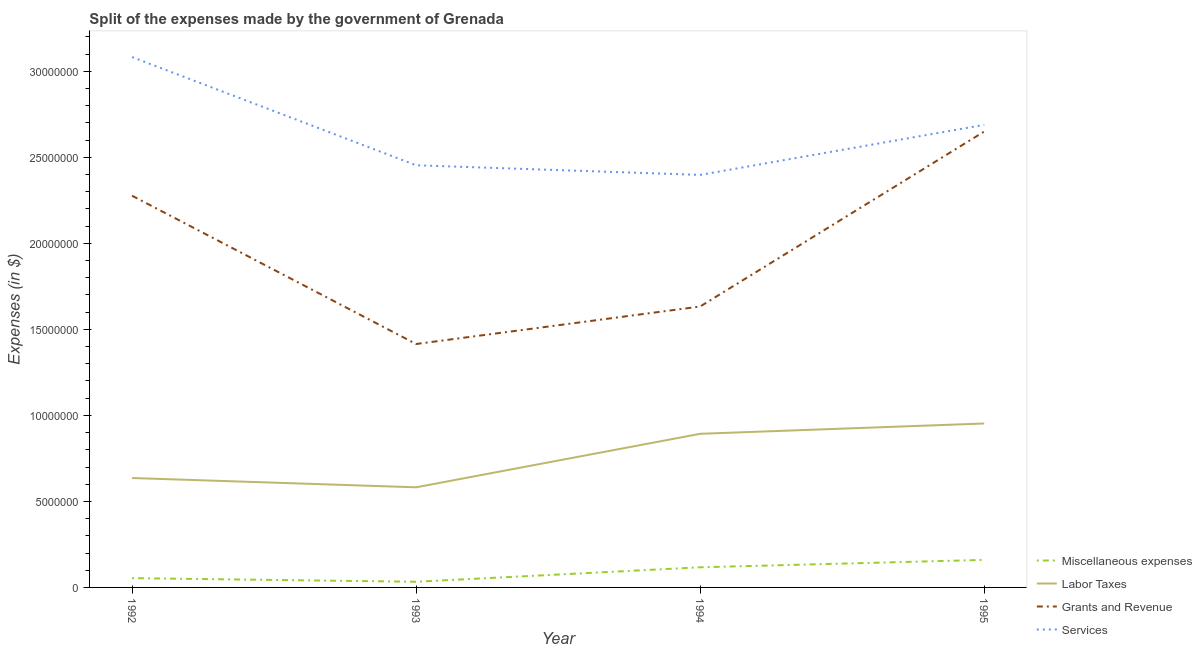How many different coloured lines are there?
Your answer should be very brief. 4. What is the amount spent on services in 1995?
Provide a short and direct response. 2.69e+07. Across all years, what is the maximum amount spent on services?
Offer a terse response. 3.08e+07. Across all years, what is the minimum amount spent on services?
Make the answer very short. 2.40e+07. In which year was the amount spent on grants and revenue minimum?
Offer a terse response. 1993. What is the total amount spent on miscellaneous expenses in the graph?
Make the answer very short. 3.64e+06. What is the difference between the amount spent on grants and revenue in 1994 and that in 1995?
Provide a succinct answer. -1.02e+07. What is the difference between the amount spent on services in 1992 and the amount spent on miscellaneous expenses in 1995?
Your answer should be very brief. 2.92e+07. What is the average amount spent on grants and revenue per year?
Make the answer very short. 1.99e+07. In the year 1992, what is the difference between the amount spent on miscellaneous expenses and amount spent on grants and revenue?
Offer a very short reply. -2.22e+07. What is the ratio of the amount spent on grants and revenue in 1993 to that in 1995?
Make the answer very short. 0.53. Is the difference between the amount spent on services in 1993 and 1994 greater than the difference between the amount spent on labor taxes in 1993 and 1994?
Offer a very short reply. Yes. What is the difference between the highest and the second highest amount spent on grants and revenue?
Ensure brevity in your answer.  3.73e+06. What is the difference between the highest and the lowest amount spent on labor taxes?
Give a very brief answer. 3.71e+06. Is the sum of the amount spent on labor taxes in 1992 and 1994 greater than the maximum amount spent on miscellaneous expenses across all years?
Ensure brevity in your answer.  Yes. Is it the case that in every year, the sum of the amount spent on services and amount spent on miscellaneous expenses is greater than the sum of amount spent on grants and revenue and amount spent on labor taxes?
Your response must be concise. Yes. Is it the case that in every year, the sum of the amount spent on miscellaneous expenses and amount spent on labor taxes is greater than the amount spent on grants and revenue?
Your answer should be compact. No. Does the amount spent on labor taxes monotonically increase over the years?
Provide a succinct answer. No. Is the amount spent on grants and revenue strictly greater than the amount spent on services over the years?
Offer a terse response. No. Where does the legend appear in the graph?
Offer a terse response. Bottom right. How many legend labels are there?
Offer a very short reply. 4. What is the title of the graph?
Ensure brevity in your answer.  Split of the expenses made by the government of Grenada. What is the label or title of the X-axis?
Give a very brief answer. Year. What is the label or title of the Y-axis?
Give a very brief answer. Expenses (in $). What is the Expenses (in $) in Miscellaneous expenses in 1992?
Provide a succinct answer. 5.40e+05. What is the Expenses (in $) of Labor Taxes in 1992?
Provide a succinct answer. 6.36e+06. What is the Expenses (in $) of Grants and Revenue in 1992?
Provide a succinct answer. 2.28e+07. What is the Expenses (in $) of Services in 1992?
Ensure brevity in your answer.  3.08e+07. What is the Expenses (in $) in Miscellaneous expenses in 1993?
Offer a very short reply. 3.30e+05. What is the Expenses (in $) in Labor Taxes in 1993?
Provide a short and direct response. 5.82e+06. What is the Expenses (in $) in Grants and Revenue in 1993?
Your answer should be very brief. 1.42e+07. What is the Expenses (in $) in Services in 1993?
Give a very brief answer. 2.45e+07. What is the Expenses (in $) of Miscellaneous expenses in 1994?
Provide a succinct answer. 1.17e+06. What is the Expenses (in $) of Labor Taxes in 1994?
Offer a terse response. 8.93e+06. What is the Expenses (in $) of Grants and Revenue in 1994?
Your answer should be very brief. 1.63e+07. What is the Expenses (in $) in Services in 1994?
Your response must be concise. 2.40e+07. What is the Expenses (in $) of Miscellaneous expenses in 1995?
Give a very brief answer. 1.60e+06. What is the Expenses (in $) in Labor Taxes in 1995?
Ensure brevity in your answer.  9.53e+06. What is the Expenses (in $) in Grants and Revenue in 1995?
Provide a short and direct response. 2.65e+07. What is the Expenses (in $) in Services in 1995?
Give a very brief answer. 2.69e+07. Across all years, what is the maximum Expenses (in $) of Miscellaneous expenses?
Offer a terse response. 1.60e+06. Across all years, what is the maximum Expenses (in $) in Labor Taxes?
Your answer should be compact. 9.53e+06. Across all years, what is the maximum Expenses (in $) of Grants and Revenue?
Offer a very short reply. 2.65e+07. Across all years, what is the maximum Expenses (in $) of Services?
Your answer should be very brief. 3.08e+07. Across all years, what is the minimum Expenses (in $) in Labor Taxes?
Ensure brevity in your answer.  5.82e+06. Across all years, what is the minimum Expenses (in $) of Grants and Revenue?
Make the answer very short. 1.42e+07. Across all years, what is the minimum Expenses (in $) of Services?
Make the answer very short. 2.40e+07. What is the total Expenses (in $) in Miscellaneous expenses in the graph?
Keep it short and to the point. 3.64e+06. What is the total Expenses (in $) of Labor Taxes in the graph?
Make the answer very short. 3.06e+07. What is the total Expenses (in $) in Grants and Revenue in the graph?
Provide a succinct answer. 7.98e+07. What is the total Expenses (in $) in Services in the graph?
Offer a terse response. 1.06e+08. What is the difference between the Expenses (in $) of Miscellaneous expenses in 1992 and that in 1993?
Your answer should be compact. 2.10e+05. What is the difference between the Expenses (in $) of Labor Taxes in 1992 and that in 1993?
Give a very brief answer. 5.40e+05. What is the difference between the Expenses (in $) of Grants and Revenue in 1992 and that in 1993?
Make the answer very short. 8.62e+06. What is the difference between the Expenses (in $) in Services in 1992 and that in 1993?
Your answer should be very brief. 6.29e+06. What is the difference between the Expenses (in $) in Miscellaneous expenses in 1992 and that in 1994?
Provide a short and direct response. -6.30e+05. What is the difference between the Expenses (in $) of Labor Taxes in 1992 and that in 1994?
Provide a short and direct response. -2.57e+06. What is the difference between the Expenses (in $) of Grants and Revenue in 1992 and that in 1994?
Make the answer very short. 6.44e+06. What is the difference between the Expenses (in $) of Services in 1992 and that in 1994?
Make the answer very short. 6.85e+06. What is the difference between the Expenses (in $) of Miscellaneous expenses in 1992 and that in 1995?
Ensure brevity in your answer.  -1.06e+06. What is the difference between the Expenses (in $) in Labor Taxes in 1992 and that in 1995?
Make the answer very short. -3.17e+06. What is the difference between the Expenses (in $) of Grants and Revenue in 1992 and that in 1995?
Your answer should be very brief. -3.73e+06. What is the difference between the Expenses (in $) of Services in 1992 and that in 1995?
Make the answer very short. 3.94e+06. What is the difference between the Expenses (in $) in Miscellaneous expenses in 1993 and that in 1994?
Offer a terse response. -8.40e+05. What is the difference between the Expenses (in $) of Labor Taxes in 1993 and that in 1994?
Provide a succinct answer. -3.11e+06. What is the difference between the Expenses (in $) of Grants and Revenue in 1993 and that in 1994?
Provide a succinct answer. -2.18e+06. What is the difference between the Expenses (in $) in Services in 1993 and that in 1994?
Provide a succinct answer. 5.60e+05. What is the difference between the Expenses (in $) in Miscellaneous expenses in 1993 and that in 1995?
Your answer should be compact. -1.27e+06. What is the difference between the Expenses (in $) of Labor Taxes in 1993 and that in 1995?
Your answer should be compact. -3.71e+06. What is the difference between the Expenses (in $) of Grants and Revenue in 1993 and that in 1995?
Your response must be concise. -1.24e+07. What is the difference between the Expenses (in $) of Services in 1993 and that in 1995?
Your response must be concise. -2.35e+06. What is the difference between the Expenses (in $) in Miscellaneous expenses in 1994 and that in 1995?
Provide a short and direct response. -4.30e+05. What is the difference between the Expenses (in $) in Labor Taxes in 1994 and that in 1995?
Give a very brief answer. -6.00e+05. What is the difference between the Expenses (in $) in Grants and Revenue in 1994 and that in 1995?
Keep it short and to the point. -1.02e+07. What is the difference between the Expenses (in $) in Services in 1994 and that in 1995?
Your answer should be very brief. -2.91e+06. What is the difference between the Expenses (in $) of Miscellaneous expenses in 1992 and the Expenses (in $) of Labor Taxes in 1993?
Make the answer very short. -5.28e+06. What is the difference between the Expenses (in $) of Miscellaneous expenses in 1992 and the Expenses (in $) of Grants and Revenue in 1993?
Give a very brief answer. -1.36e+07. What is the difference between the Expenses (in $) of Miscellaneous expenses in 1992 and the Expenses (in $) of Services in 1993?
Your answer should be compact. -2.40e+07. What is the difference between the Expenses (in $) of Labor Taxes in 1992 and the Expenses (in $) of Grants and Revenue in 1993?
Keep it short and to the point. -7.79e+06. What is the difference between the Expenses (in $) of Labor Taxes in 1992 and the Expenses (in $) of Services in 1993?
Your answer should be very brief. -1.82e+07. What is the difference between the Expenses (in $) of Grants and Revenue in 1992 and the Expenses (in $) of Services in 1993?
Your response must be concise. -1.77e+06. What is the difference between the Expenses (in $) of Miscellaneous expenses in 1992 and the Expenses (in $) of Labor Taxes in 1994?
Provide a short and direct response. -8.39e+06. What is the difference between the Expenses (in $) in Miscellaneous expenses in 1992 and the Expenses (in $) in Grants and Revenue in 1994?
Provide a succinct answer. -1.58e+07. What is the difference between the Expenses (in $) of Miscellaneous expenses in 1992 and the Expenses (in $) of Services in 1994?
Your answer should be compact. -2.34e+07. What is the difference between the Expenses (in $) of Labor Taxes in 1992 and the Expenses (in $) of Grants and Revenue in 1994?
Offer a terse response. -9.97e+06. What is the difference between the Expenses (in $) of Labor Taxes in 1992 and the Expenses (in $) of Services in 1994?
Offer a very short reply. -1.76e+07. What is the difference between the Expenses (in $) in Grants and Revenue in 1992 and the Expenses (in $) in Services in 1994?
Provide a succinct answer. -1.21e+06. What is the difference between the Expenses (in $) in Miscellaneous expenses in 1992 and the Expenses (in $) in Labor Taxes in 1995?
Ensure brevity in your answer.  -8.99e+06. What is the difference between the Expenses (in $) of Miscellaneous expenses in 1992 and the Expenses (in $) of Grants and Revenue in 1995?
Your answer should be compact. -2.60e+07. What is the difference between the Expenses (in $) in Miscellaneous expenses in 1992 and the Expenses (in $) in Services in 1995?
Your response must be concise. -2.64e+07. What is the difference between the Expenses (in $) in Labor Taxes in 1992 and the Expenses (in $) in Grants and Revenue in 1995?
Make the answer very short. -2.01e+07. What is the difference between the Expenses (in $) in Labor Taxes in 1992 and the Expenses (in $) in Services in 1995?
Your answer should be compact. -2.05e+07. What is the difference between the Expenses (in $) of Grants and Revenue in 1992 and the Expenses (in $) of Services in 1995?
Make the answer very short. -4.12e+06. What is the difference between the Expenses (in $) in Miscellaneous expenses in 1993 and the Expenses (in $) in Labor Taxes in 1994?
Provide a short and direct response. -8.60e+06. What is the difference between the Expenses (in $) of Miscellaneous expenses in 1993 and the Expenses (in $) of Grants and Revenue in 1994?
Ensure brevity in your answer.  -1.60e+07. What is the difference between the Expenses (in $) of Miscellaneous expenses in 1993 and the Expenses (in $) of Services in 1994?
Give a very brief answer. -2.36e+07. What is the difference between the Expenses (in $) in Labor Taxes in 1993 and the Expenses (in $) in Grants and Revenue in 1994?
Offer a very short reply. -1.05e+07. What is the difference between the Expenses (in $) in Labor Taxes in 1993 and the Expenses (in $) in Services in 1994?
Provide a short and direct response. -1.82e+07. What is the difference between the Expenses (in $) of Grants and Revenue in 1993 and the Expenses (in $) of Services in 1994?
Offer a very short reply. -9.83e+06. What is the difference between the Expenses (in $) of Miscellaneous expenses in 1993 and the Expenses (in $) of Labor Taxes in 1995?
Provide a short and direct response. -9.20e+06. What is the difference between the Expenses (in $) of Miscellaneous expenses in 1993 and the Expenses (in $) of Grants and Revenue in 1995?
Your answer should be compact. -2.62e+07. What is the difference between the Expenses (in $) of Miscellaneous expenses in 1993 and the Expenses (in $) of Services in 1995?
Keep it short and to the point. -2.66e+07. What is the difference between the Expenses (in $) in Labor Taxes in 1993 and the Expenses (in $) in Grants and Revenue in 1995?
Make the answer very short. -2.07e+07. What is the difference between the Expenses (in $) of Labor Taxes in 1993 and the Expenses (in $) of Services in 1995?
Provide a short and direct response. -2.11e+07. What is the difference between the Expenses (in $) of Grants and Revenue in 1993 and the Expenses (in $) of Services in 1995?
Ensure brevity in your answer.  -1.27e+07. What is the difference between the Expenses (in $) of Miscellaneous expenses in 1994 and the Expenses (in $) of Labor Taxes in 1995?
Your answer should be very brief. -8.36e+06. What is the difference between the Expenses (in $) of Miscellaneous expenses in 1994 and the Expenses (in $) of Grants and Revenue in 1995?
Your response must be concise. -2.53e+07. What is the difference between the Expenses (in $) of Miscellaneous expenses in 1994 and the Expenses (in $) of Services in 1995?
Your answer should be very brief. -2.57e+07. What is the difference between the Expenses (in $) of Labor Taxes in 1994 and the Expenses (in $) of Grants and Revenue in 1995?
Give a very brief answer. -1.76e+07. What is the difference between the Expenses (in $) in Labor Taxes in 1994 and the Expenses (in $) in Services in 1995?
Your response must be concise. -1.80e+07. What is the difference between the Expenses (in $) of Grants and Revenue in 1994 and the Expenses (in $) of Services in 1995?
Give a very brief answer. -1.06e+07. What is the average Expenses (in $) of Miscellaneous expenses per year?
Keep it short and to the point. 9.10e+05. What is the average Expenses (in $) in Labor Taxes per year?
Make the answer very short. 7.66e+06. What is the average Expenses (in $) of Grants and Revenue per year?
Your answer should be very brief. 1.99e+07. What is the average Expenses (in $) in Services per year?
Provide a short and direct response. 2.66e+07. In the year 1992, what is the difference between the Expenses (in $) of Miscellaneous expenses and Expenses (in $) of Labor Taxes?
Provide a succinct answer. -5.82e+06. In the year 1992, what is the difference between the Expenses (in $) in Miscellaneous expenses and Expenses (in $) in Grants and Revenue?
Ensure brevity in your answer.  -2.22e+07. In the year 1992, what is the difference between the Expenses (in $) of Miscellaneous expenses and Expenses (in $) of Services?
Give a very brief answer. -3.03e+07. In the year 1992, what is the difference between the Expenses (in $) of Labor Taxes and Expenses (in $) of Grants and Revenue?
Your response must be concise. -1.64e+07. In the year 1992, what is the difference between the Expenses (in $) of Labor Taxes and Expenses (in $) of Services?
Keep it short and to the point. -2.45e+07. In the year 1992, what is the difference between the Expenses (in $) of Grants and Revenue and Expenses (in $) of Services?
Offer a very short reply. -8.06e+06. In the year 1993, what is the difference between the Expenses (in $) of Miscellaneous expenses and Expenses (in $) of Labor Taxes?
Your answer should be very brief. -5.49e+06. In the year 1993, what is the difference between the Expenses (in $) in Miscellaneous expenses and Expenses (in $) in Grants and Revenue?
Provide a succinct answer. -1.38e+07. In the year 1993, what is the difference between the Expenses (in $) of Miscellaneous expenses and Expenses (in $) of Services?
Your response must be concise. -2.42e+07. In the year 1993, what is the difference between the Expenses (in $) in Labor Taxes and Expenses (in $) in Grants and Revenue?
Keep it short and to the point. -8.33e+06. In the year 1993, what is the difference between the Expenses (in $) in Labor Taxes and Expenses (in $) in Services?
Offer a very short reply. -1.87e+07. In the year 1993, what is the difference between the Expenses (in $) in Grants and Revenue and Expenses (in $) in Services?
Your response must be concise. -1.04e+07. In the year 1994, what is the difference between the Expenses (in $) of Miscellaneous expenses and Expenses (in $) of Labor Taxes?
Your response must be concise. -7.76e+06. In the year 1994, what is the difference between the Expenses (in $) of Miscellaneous expenses and Expenses (in $) of Grants and Revenue?
Your response must be concise. -1.52e+07. In the year 1994, what is the difference between the Expenses (in $) in Miscellaneous expenses and Expenses (in $) in Services?
Your answer should be compact. -2.28e+07. In the year 1994, what is the difference between the Expenses (in $) of Labor Taxes and Expenses (in $) of Grants and Revenue?
Provide a succinct answer. -7.40e+06. In the year 1994, what is the difference between the Expenses (in $) of Labor Taxes and Expenses (in $) of Services?
Give a very brief answer. -1.50e+07. In the year 1994, what is the difference between the Expenses (in $) of Grants and Revenue and Expenses (in $) of Services?
Give a very brief answer. -7.65e+06. In the year 1995, what is the difference between the Expenses (in $) of Miscellaneous expenses and Expenses (in $) of Labor Taxes?
Make the answer very short. -7.93e+06. In the year 1995, what is the difference between the Expenses (in $) in Miscellaneous expenses and Expenses (in $) in Grants and Revenue?
Make the answer very short. -2.49e+07. In the year 1995, what is the difference between the Expenses (in $) in Miscellaneous expenses and Expenses (in $) in Services?
Your answer should be very brief. -2.53e+07. In the year 1995, what is the difference between the Expenses (in $) of Labor Taxes and Expenses (in $) of Grants and Revenue?
Offer a very short reply. -1.70e+07. In the year 1995, what is the difference between the Expenses (in $) of Labor Taxes and Expenses (in $) of Services?
Provide a short and direct response. -1.74e+07. In the year 1995, what is the difference between the Expenses (in $) of Grants and Revenue and Expenses (in $) of Services?
Offer a very short reply. -3.90e+05. What is the ratio of the Expenses (in $) in Miscellaneous expenses in 1992 to that in 1993?
Your answer should be compact. 1.64. What is the ratio of the Expenses (in $) in Labor Taxes in 1992 to that in 1993?
Make the answer very short. 1.09. What is the ratio of the Expenses (in $) of Grants and Revenue in 1992 to that in 1993?
Keep it short and to the point. 1.61. What is the ratio of the Expenses (in $) of Services in 1992 to that in 1993?
Make the answer very short. 1.26. What is the ratio of the Expenses (in $) of Miscellaneous expenses in 1992 to that in 1994?
Your answer should be compact. 0.46. What is the ratio of the Expenses (in $) of Labor Taxes in 1992 to that in 1994?
Provide a short and direct response. 0.71. What is the ratio of the Expenses (in $) of Grants and Revenue in 1992 to that in 1994?
Provide a short and direct response. 1.39. What is the ratio of the Expenses (in $) in Services in 1992 to that in 1994?
Keep it short and to the point. 1.29. What is the ratio of the Expenses (in $) of Miscellaneous expenses in 1992 to that in 1995?
Your response must be concise. 0.34. What is the ratio of the Expenses (in $) in Labor Taxes in 1992 to that in 1995?
Ensure brevity in your answer.  0.67. What is the ratio of the Expenses (in $) in Grants and Revenue in 1992 to that in 1995?
Keep it short and to the point. 0.86. What is the ratio of the Expenses (in $) of Services in 1992 to that in 1995?
Give a very brief answer. 1.15. What is the ratio of the Expenses (in $) of Miscellaneous expenses in 1993 to that in 1994?
Your answer should be very brief. 0.28. What is the ratio of the Expenses (in $) in Labor Taxes in 1993 to that in 1994?
Provide a succinct answer. 0.65. What is the ratio of the Expenses (in $) of Grants and Revenue in 1993 to that in 1994?
Give a very brief answer. 0.87. What is the ratio of the Expenses (in $) in Services in 1993 to that in 1994?
Your answer should be compact. 1.02. What is the ratio of the Expenses (in $) in Miscellaneous expenses in 1993 to that in 1995?
Keep it short and to the point. 0.21. What is the ratio of the Expenses (in $) in Labor Taxes in 1993 to that in 1995?
Your answer should be very brief. 0.61. What is the ratio of the Expenses (in $) of Grants and Revenue in 1993 to that in 1995?
Ensure brevity in your answer.  0.53. What is the ratio of the Expenses (in $) in Services in 1993 to that in 1995?
Your response must be concise. 0.91. What is the ratio of the Expenses (in $) in Miscellaneous expenses in 1994 to that in 1995?
Your answer should be very brief. 0.73. What is the ratio of the Expenses (in $) of Labor Taxes in 1994 to that in 1995?
Provide a succinct answer. 0.94. What is the ratio of the Expenses (in $) in Grants and Revenue in 1994 to that in 1995?
Give a very brief answer. 0.62. What is the ratio of the Expenses (in $) in Services in 1994 to that in 1995?
Your response must be concise. 0.89. What is the difference between the highest and the second highest Expenses (in $) of Miscellaneous expenses?
Ensure brevity in your answer.  4.30e+05. What is the difference between the highest and the second highest Expenses (in $) in Labor Taxes?
Your response must be concise. 6.00e+05. What is the difference between the highest and the second highest Expenses (in $) in Grants and Revenue?
Make the answer very short. 3.73e+06. What is the difference between the highest and the second highest Expenses (in $) in Services?
Make the answer very short. 3.94e+06. What is the difference between the highest and the lowest Expenses (in $) in Miscellaneous expenses?
Make the answer very short. 1.27e+06. What is the difference between the highest and the lowest Expenses (in $) of Labor Taxes?
Ensure brevity in your answer.  3.71e+06. What is the difference between the highest and the lowest Expenses (in $) in Grants and Revenue?
Make the answer very short. 1.24e+07. What is the difference between the highest and the lowest Expenses (in $) of Services?
Make the answer very short. 6.85e+06. 